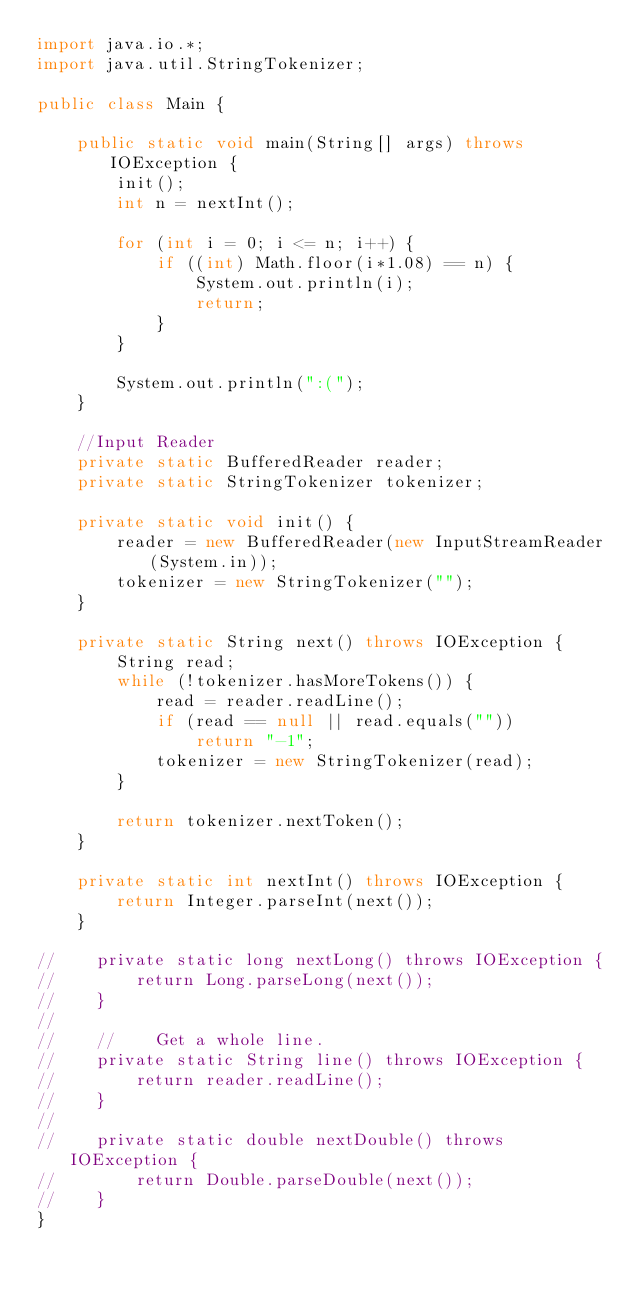Convert code to text. <code><loc_0><loc_0><loc_500><loc_500><_Java_>import java.io.*;
import java.util.StringTokenizer;

public class Main {

    public static void main(String[] args) throws IOException {
        init();
        int n = nextInt();

        for (int i = 0; i <= n; i++) {
            if ((int) Math.floor(i*1.08) == n) {
                System.out.println(i);
                return;
            }
        }

        System.out.println(":(");
    }

    //Input Reader
    private static BufferedReader reader;
    private static StringTokenizer tokenizer;

    private static void init() {
        reader = new BufferedReader(new InputStreamReader(System.in));
        tokenizer = new StringTokenizer("");
    }

    private static String next() throws IOException {
        String read;
        while (!tokenizer.hasMoreTokens()) {
            read = reader.readLine();
            if (read == null || read.equals(""))
                return "-1";
            tokenizer = new StringTokenizer(read);
        }

        return tokenizer.nextToken();
    }

    private static int nextInt() throws IOException {
        return Integer.parseInt(next());
    }

//    private static long nextLong() throws IOException {
//        return Long.parseLong(next());
//    }
//
//    //    Get a whole line.
//    private static String line() throws IOException {
//        return reader.readLine();
//    }
//
//    private static double nextDouble() throws IOException {
//        return Double.parseDouble(next());
//    }
}</code> 